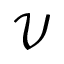<formula> <loc_0><loc_0><loc_500><loc_500>\mathcal { V }</formula> 